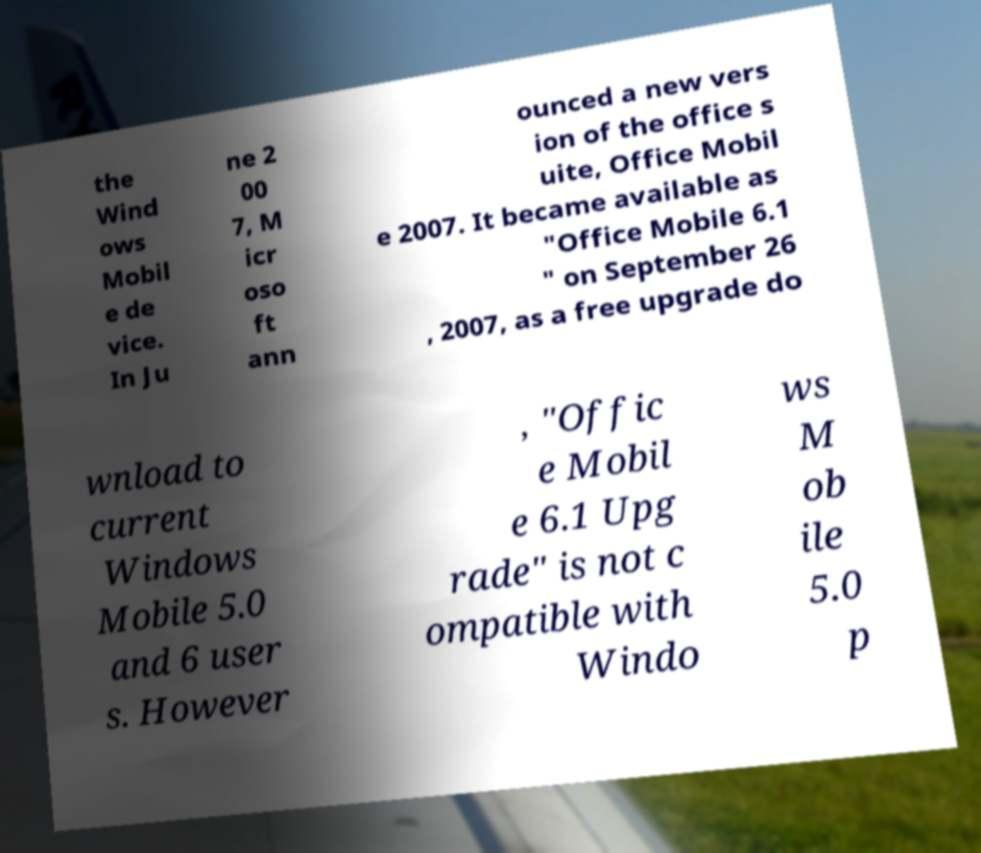For documentation purposes, I need the text within this image transcribed. Could you provide that? the Wind ows Mobil e de vice. In Ju ne 2 00 7, M icr oso ft ann ounced a new vers ion of the office s uite, Office Mobil e 2007. It became available as "Office Mobile 6.1 " on September 26 , 2007, as a free upgrade do wnload to current Windows Mobile 5.0 and 6 user s. However , "Offic e Mobil e 6.1 Upg rade" is not c ompatible with Windo ws M ob ile 5.0 p 